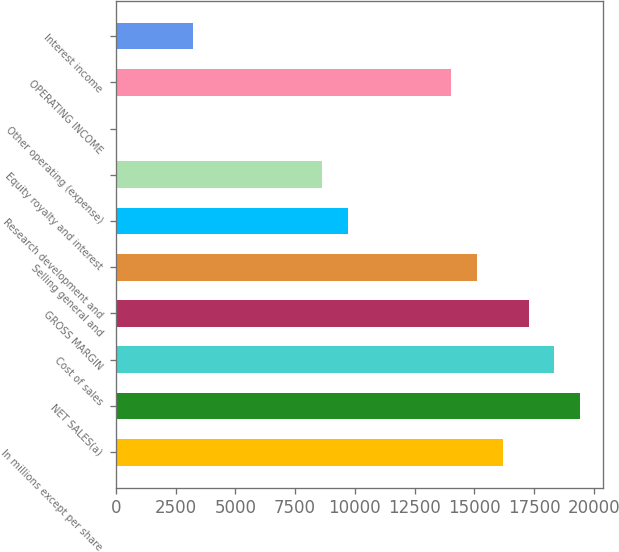Convert chart. <chart><loc_0><loc_0><loc_500><loc_500><bar_chart><fcel>In millions except per share<fcel>NET SALES(a)<fcel>Cost of sales<fcel>GROSS MARGIN<fcel>Selling general and<fcel>Research development and<fcel>Equity royalty and interest<fcel>Other operating (expense)<fcel>OPERATING INCOME<fcel>Interest income<nl><fcel>16199.5<fcel>19439.2<fcel>18359.3<fcel>17279.4<fcel>15119.6<fcel>9720.1<fcel>8640.2<fcel>1<fcel>14039.7<fcel>3240.7<nl></chart> 